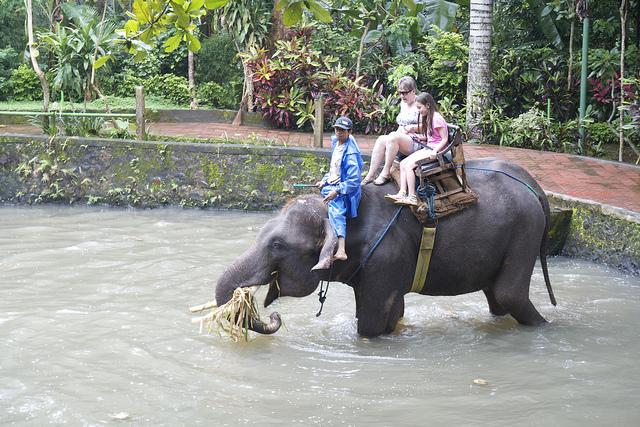How many people are seated on top of the elephant eating in the pool? Please explain your reasoning. three. There are three people. 